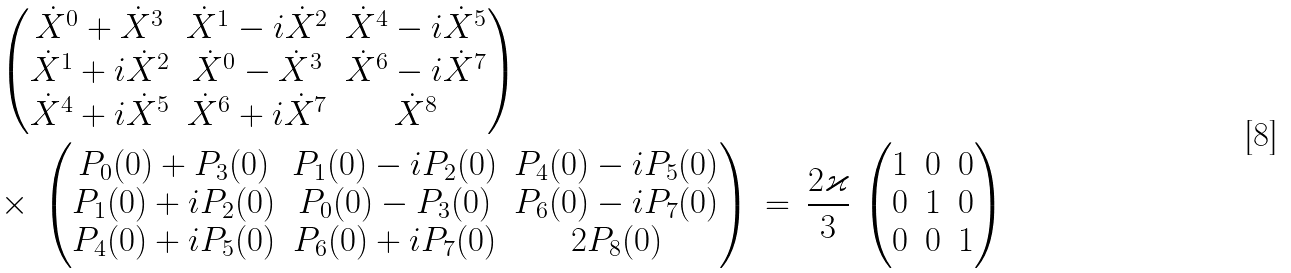<formula> <loc_0><loc_0><loc_500><loc_500>& \begin{pmatrix} \dot { X } ^ { 0 } + \dot { X } ^ { 3 } & \dot { X } ^ { 1 } - i \dot { X } ^ { 2 } & \dot { X } ^ { 4 } - i \dot { X } ^ { 5 } \\ \dot { X } ^ { 1 } + i \dot { X } ^ { 2 } & \dot { X } ^ { 0 } - \dot { X } ^ { 3 } & \dot { X } ^ { 6 } - i \dot { X } ^ { 7 } \\ \dot { X } ^ { 4 } + i \dot { X } ^ { 5 } & \dot { X } ^ { 6 } + i \dot { X } ^ { 7 } & \dot { X } ^ { 8 } \end{pmatrix} \\ & \times \, \begin{pmatrix} P _ { 0 } ( 0 ) + P _ { 3 } ( 0 ) & P _ { 1 } ( 0 ) - i P _ { 2 } ( 0 ) & P _ { 4 } ( 0 ) - i P _ { 5 } ( 0 ) \\ P _ { 1 } ( 0 ) + i P _ { 2 } ( 0 ) & P _ { 0 } ( 0 ) - P _ { 3 } ( 0 ) & P _ { 6 } ( 0 ) - i P _ { 7 } ( 0 ) \\ P _ { 4 } ( 0 ) + i P _ { 5 } ( 0 ) & P _ { 6 } ( 0 ) + i P _ { 7 } ( 0 ) & 2 P _ { 8 } ( 0 ) \end{pmatrix} \, = \, \frac { 2 \varkappa } { 3 } \, \begin{pmatrix} 1 & 0 & 0 \\ 0 & 1 & 0 \\ 0 & 0 & 1 \\ \end{pmatrix}</formula> 